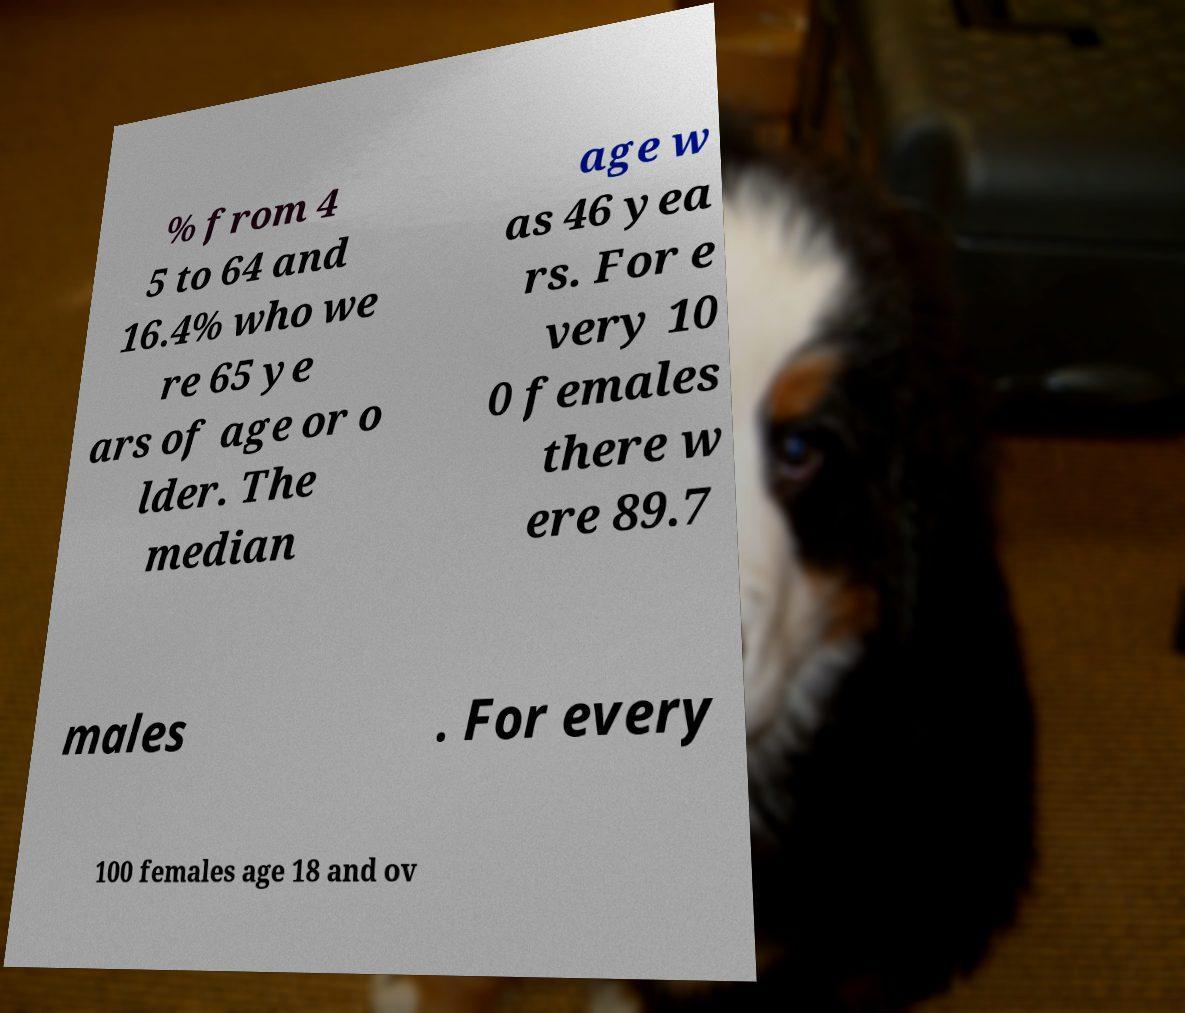There's text embedded in this image that I need extracted. Can you transcribe it verbatim? % from 4 5 to 64 and 16.4% who we re 65 ye ars of age or o lder. The median age w as 46 yea rs. For e very 10 0 females there w ere 89.7 males . For every 100 females age 18 and ov 